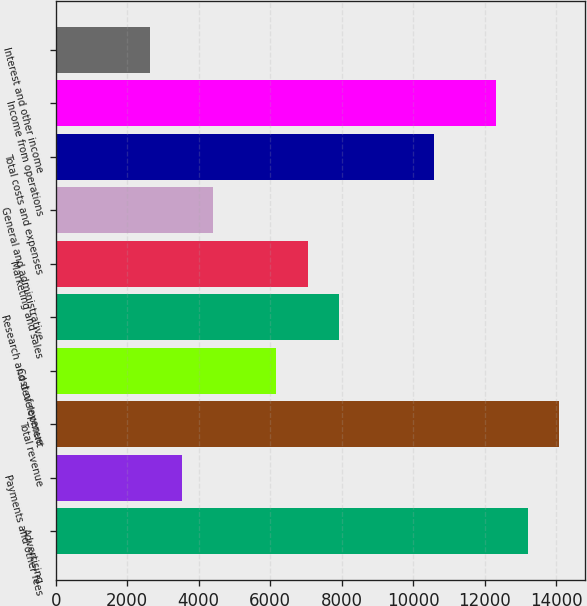<chart> <loc_0><loc_0><loc_500><loc_500><bar_chart><fcel>Advertising<fcel>Payments and other fees<fcel>Total revenue<fcel>Cost of revenue<fcel>Research and development<fcel>Marketing and sales<fcel>General and administrative<fcel>Total costs and expenses<fcel>Income from operations<fcel>Interest and other income<nl><fcel>13212.9<fcel>3524.33<fcel>14093.7<fcel>6166.67<fcel>7928.23<fcel>7047.45<fcel>4405.11<fcel>10570.6<fcel>12332.1<fcel>2643.55<nl></chart> 